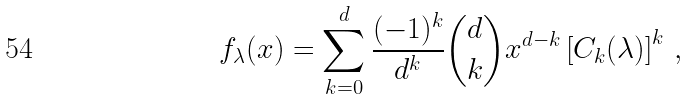<formula> <loc_0><loc_0><loc_500><loc_500>f _ { \lambda } ( x ) = \sum _ { k = 0 } ^ { d } \frac { ( - 1 ) ^ { k } } { d ^ { k } } { d \choose k } x ^ { d - k } \left [ C _ { k } ( \lambda ) \right ] ^ { k } \, ,</formula> 